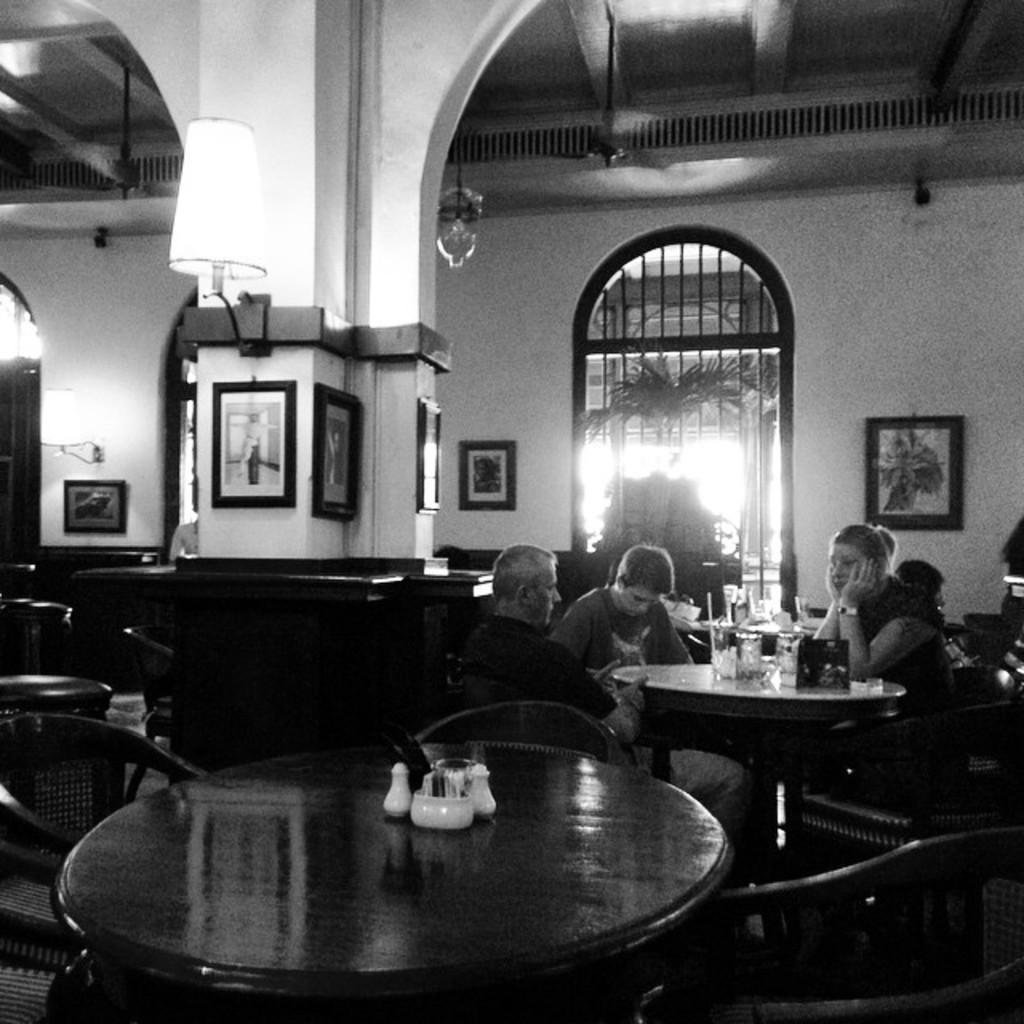How many people are in the image? There is a group of people in the image. Can you describe the interaction between the woman and the person in front of her? A woman is staring at a person in front of her. What type of cushion is the woman using to brush her hands in the image? There is no cushion or brushing of hands present in the image. 